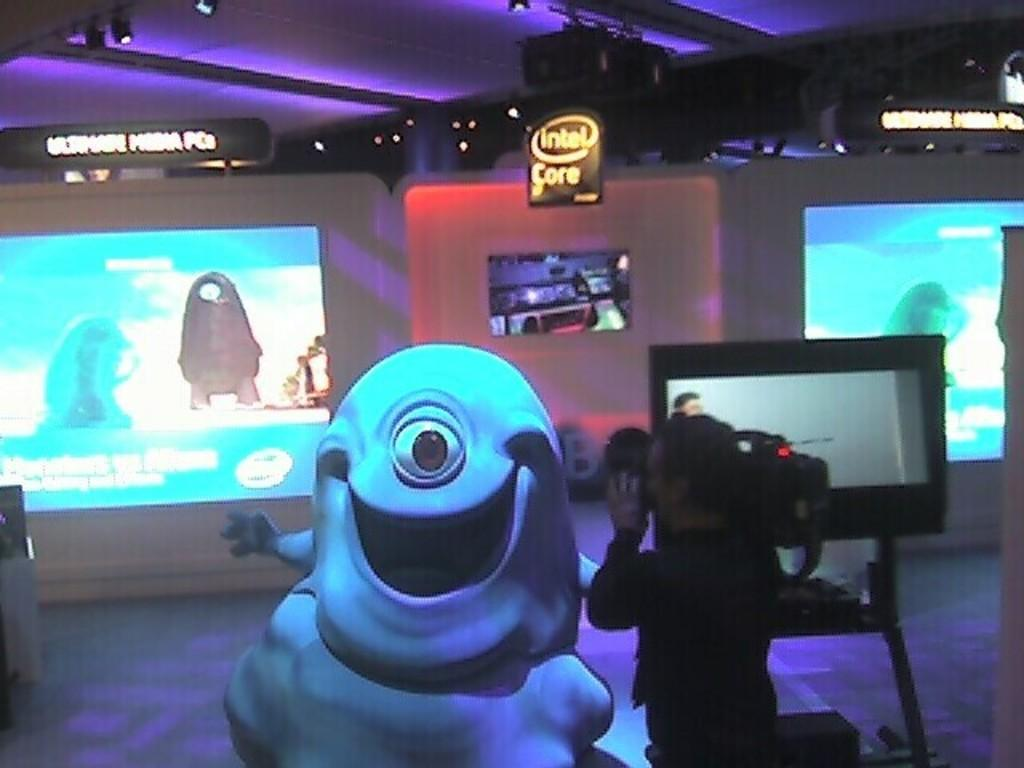<image>
Provide a brief description of the given image. a room with big monitors and an Intel Core sign 